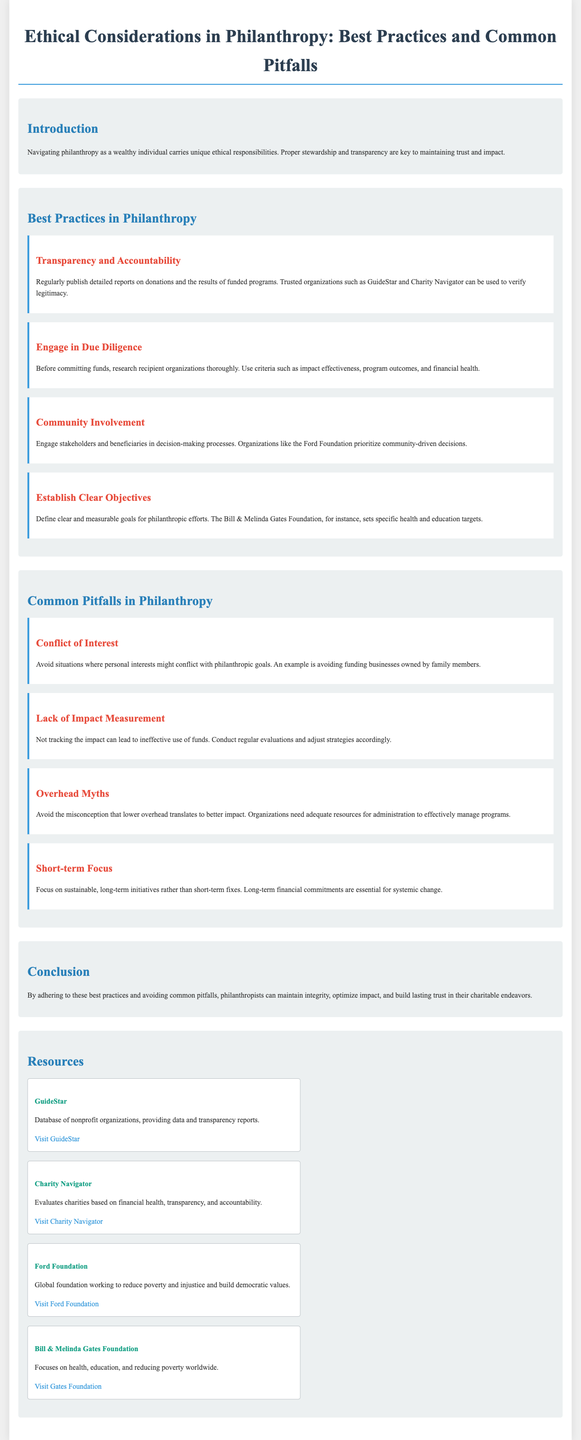what is the main ethical responsibility of wealthy individuals in philanthropy? The main ethical responsibility is proper stewardship and transparency.
Answer: proper stewardship and transparency what organization evaluates charities based on financial health? This organization is Charity Navigator.
Answer: Charity Navigator which foundation prioritizes community-driven decisions? The foundation that prioritizes community-driven decisions is the Ford Foundation.
Answer: Ford Foundation what is a common pitfall related to measuring impact? A common pitfall is the lack of impact measurement.
Answer: lack of impact measurement what should philanthropists define for their efforts? Philanthropists should define clear and measurable goals.
Answer: clear and measurable goals what is one misconception about overhead costs in non-profits? The misconception is that lower overhead translates to better impact.
Answer: lower overhead translates to better impact how can philanthropists maintain trust in their charitable endeavors? By adhering to best practices and avoiding common pitfalls.
Answer: adhering to best practices and avoiding common pitfalls name one resource for checking the legitimacy of organizations. One resource is GuideStar.
Answer: GuideStar what approach should be avoided due to conflict of interest? Funding businesses owned by family members should be avoided.
Answer: Funding businesses owned by family members 